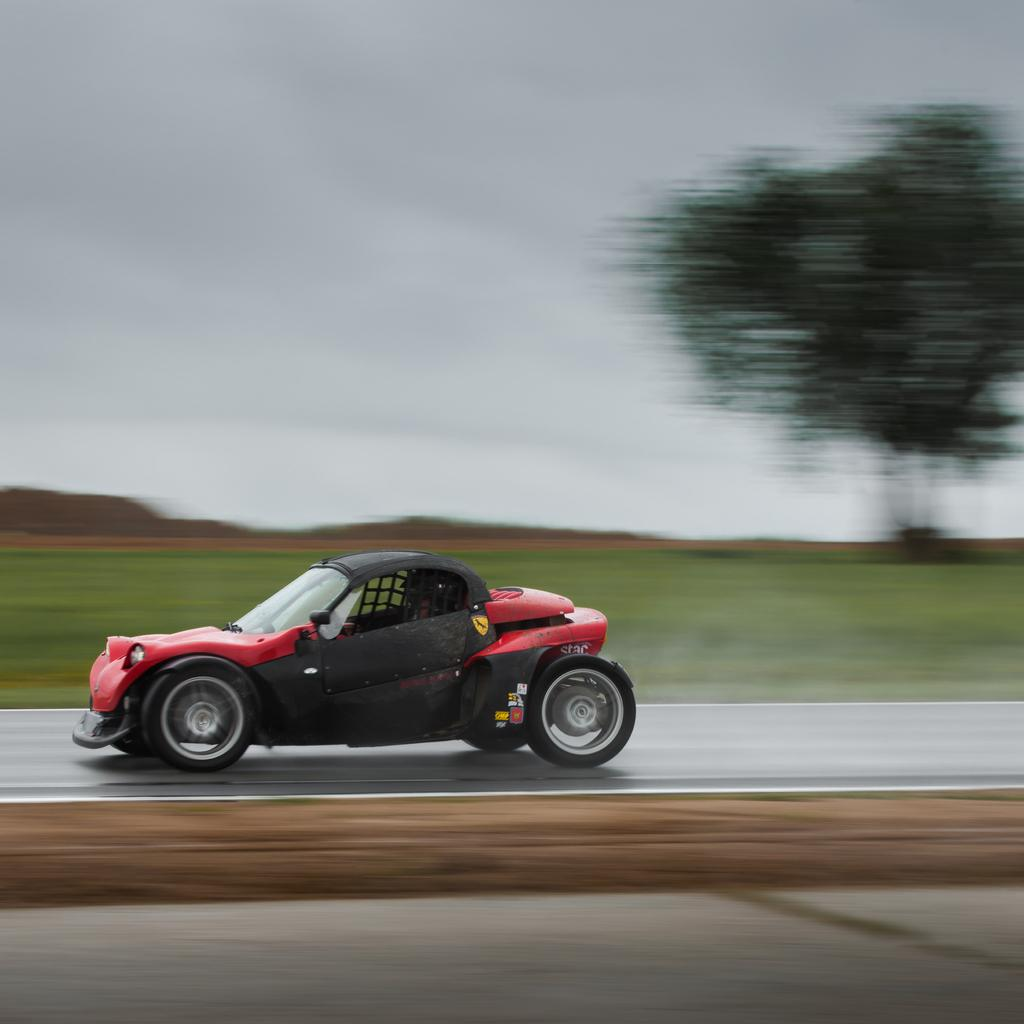What is the condition of the background in the image? The background portion of the picture is blurred. What type of natural element can be seen in the image? There is a tree visible in the image. What part of the natural environment is visible in the image? The sky is visible in the image. What type of man-made object is present on the road in the image? There is a vehicle on the road in the image. What type of nut is being cracked by the tree in the image? There is no nut or cracking activity present in the image; it features a tree and a blurred background. 